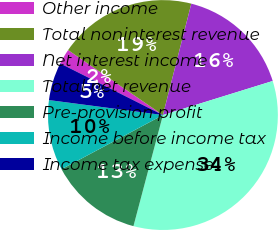Convert chart to OTSL. <chart><loc_0><loc_0><loc_500><loc_500><pie_chart><fcel>Other income<fcel>Total noninterest revenue<fcel>Net interest income<fcel>Total net revenue<fcel>Pre-provision profit<fcel>Income before income tax<fcel>Income tax expense<nl><fcel>2.15%<fcel>19.41%<fcel>16.24%<fcel>33.91%<fcel>13.06%<fcel>9.89%<fcel>5.33%<nl></chart> 